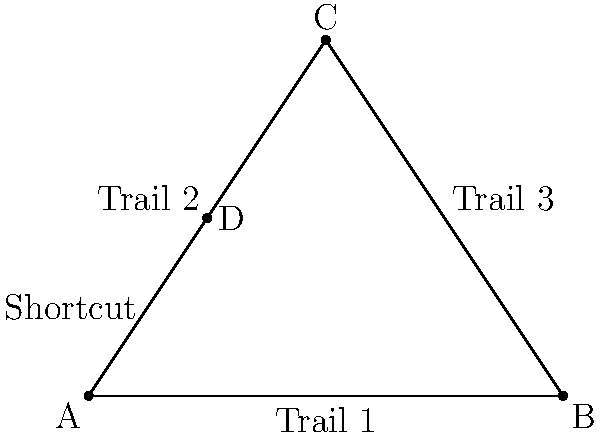During a hiking trip, you come across three main trails forming a triangle ABC, with a shortcut path AD intersecting the triangle. If the angles $\angle CAD$ and $\angle ACD$ are equal, and $\angle BAD = \angle BCD$, what can you conclude about triangles ACD and ABD? Let's approach this step-by-step:

1. We are given that $\angle CAD = \angle ACD$. This means that triangle ACD is isosceles, with AC = CD.

2. We are also given that $\angle BAD = \angle BCD$. This is an important piece of information.

3. In triangle ABC, we know that $\angle BAC + \angle BCA + \angle ABC = 180°$ (sum of angles in a triangle).

4. Now, let's look at the angles around point A:
   $\angle BAC = \angle BAD + \angle CAD$
   
5. Similarly, for the angles around point C:
   $\angle BCA = \angle BCD + \angle ACD$

6. But we know that $\angle BAD = \angle BCD$ and $\angle CAD = \angle ACD$

7. Therefore, $\angle BAC = \angle BCA$

8. This means that triangle ABC is also isosceles, with AB = BC.

9. Now, in triangle ABD:
   - AD is common to both triangles
   - $\angle BAD = \angle BCD$ (given)
   - AB = BC (as we proved ABC is isosceles)

10. These three conditions satisfy the AAS (Angle-Angle-Side) congruence criterion.

Therefore, triangles ACD and ABD are congruent.
Answer: Congruent 